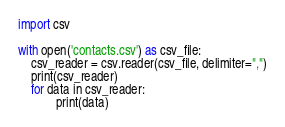<code> <loc_0><loc_0><loc_500><loc_500><_Python_>import csv

with open('contacts.csv') as csv_file:
    csv_reader = csv.reader(csv_file, delimiter=",")
    print(csv_reader)
    for data in csv_reader:
            print(data)
</code> 